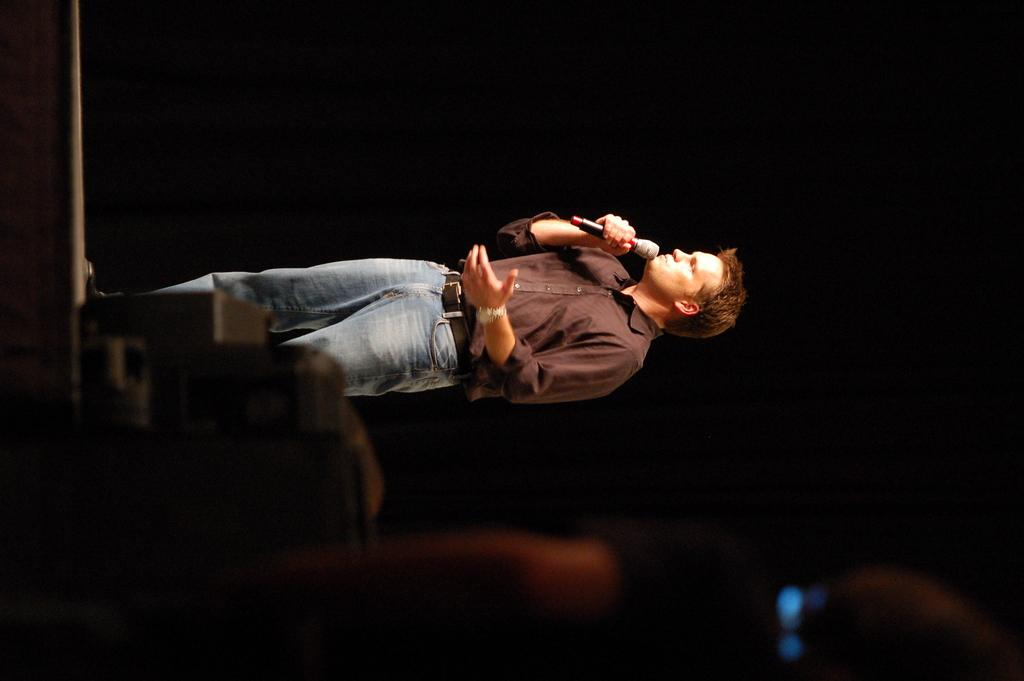What is the man in the image doing? The man is standing on a dais and speaking into a microphone. Can you describe the object at the bottom left of the image? Unfortunately, the provided facts do not give any information about the object at the bottom left of the image. What is the color of the backdrop in the image? The backdrop is described as dark in the image. How does the man start his speech in the image? The provided facts do not give any information about how the man starts his speech in the image. What type of act is the man performing in the image? The provided facts do not indicate that the man is performing an act in the image; he is simply standing on a dais and speaking into a microphone. 